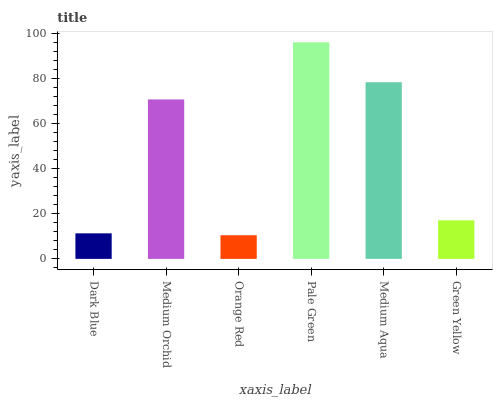Is Orange Red the minimum?
Answer yes or no. Yes. Is Pale Green the maximum?
Answer yes or no. Yes. Is Medium Orchid the minimum?
Answer yes or no. No. Is Medium Orchid the maximum?
Answer yes or no. No. Is Medium Orchid greater than Dark Blue?
Answer yes or no. Yes. Is Dark Blue less than Medium Orchid?
Answer yes or no. Yes. Is Dark Blue greater than Medium Orchid?
Answer yes or no. No. Is Medium Orchid less than Dark Blue?
Answer yes or no. No. Is Medium Orchid the high median?
Answer yes or no. Yes. Is Green Yellow the low median?
Answer yes or no. Yes. Is Medium Aqua the high median?
Answer yes or no. No. Is Orange Red the low median?
Answer yes or no. No. 